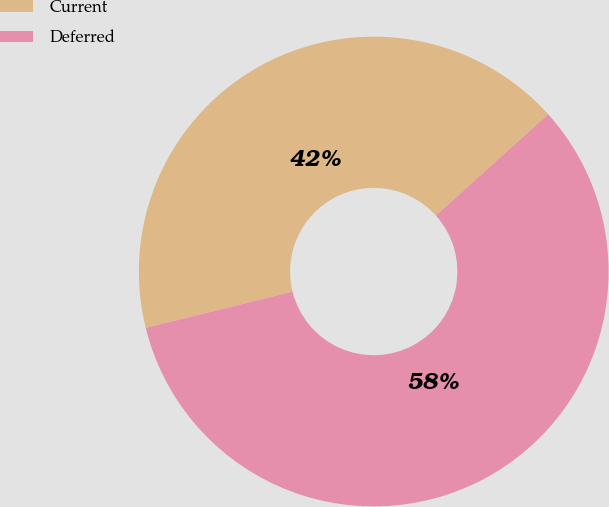Convert chart. <chart><loc_0><loc_0><loc_500><loc_500><pie_chart><fcel>Current<fcel>Deferred<nl><fcel>42.18%<fcel>57.82%<nl></chart> 